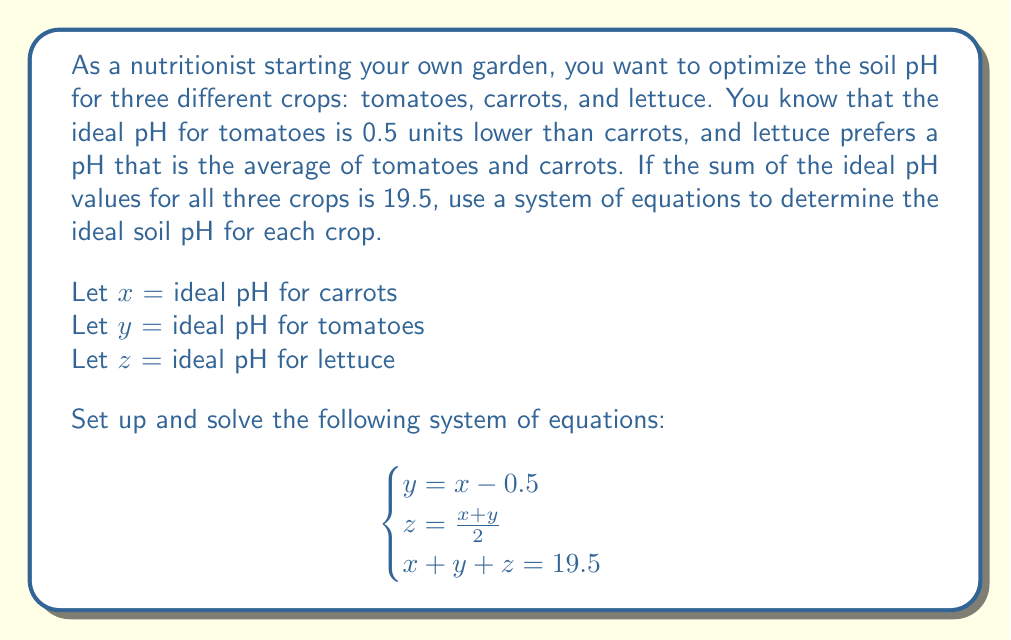Provide a solution to this math problem. Let's solve this system of equations step by step:

1) From the first equation: $y = x - 0.5$

2) Substitute this into the second equation:
   $z = \frac{x + (x - 0.5)}{2} = \frac{2x - 0.5}{2} = x - 0.25$

3) Now we can substitute both $y$ and $z$ into the third equation:
   $x + (x - 0.5) + (x - 0.25) = 19.5$

4) Simplify:
   $x + x - 0.5 + x - 0.25 = 19.5$
   $3x - 0.75 = 19.5$

5) Solve for $x$:
   $3x = 20.25$
   $x = 6.75$

6) Now that we know $x$, we can find $y$ and $z$:
   $y = x - 0.5 = 6.75 - 0.5 = 6.25$
   $z = x - 0.25 = 6.75 - 0.25 = 6.5$

Therefore, the ideal pH levels are:
Carrots (x): 6.75
Tomatoes (y): 6.25
Lettuce (z): 6.5

We can verify that these values satisfy all equations:
- $y = x - 0.5$: $6.25 = 6.75 - 0.5$ (True)
- $z = \frac{x + y}{2}$: $6.5 = \frac{6.75 + 6.25}{2}$ (True)
- $x + y + z = 19.5$: $6.75 + 6.25 + 6.5 = 19.5$ (True)
Answer: The ideal soil pH levels are:
Carrots: 6.75
Tomatoes: 6.25
Lettuce: 6.5 